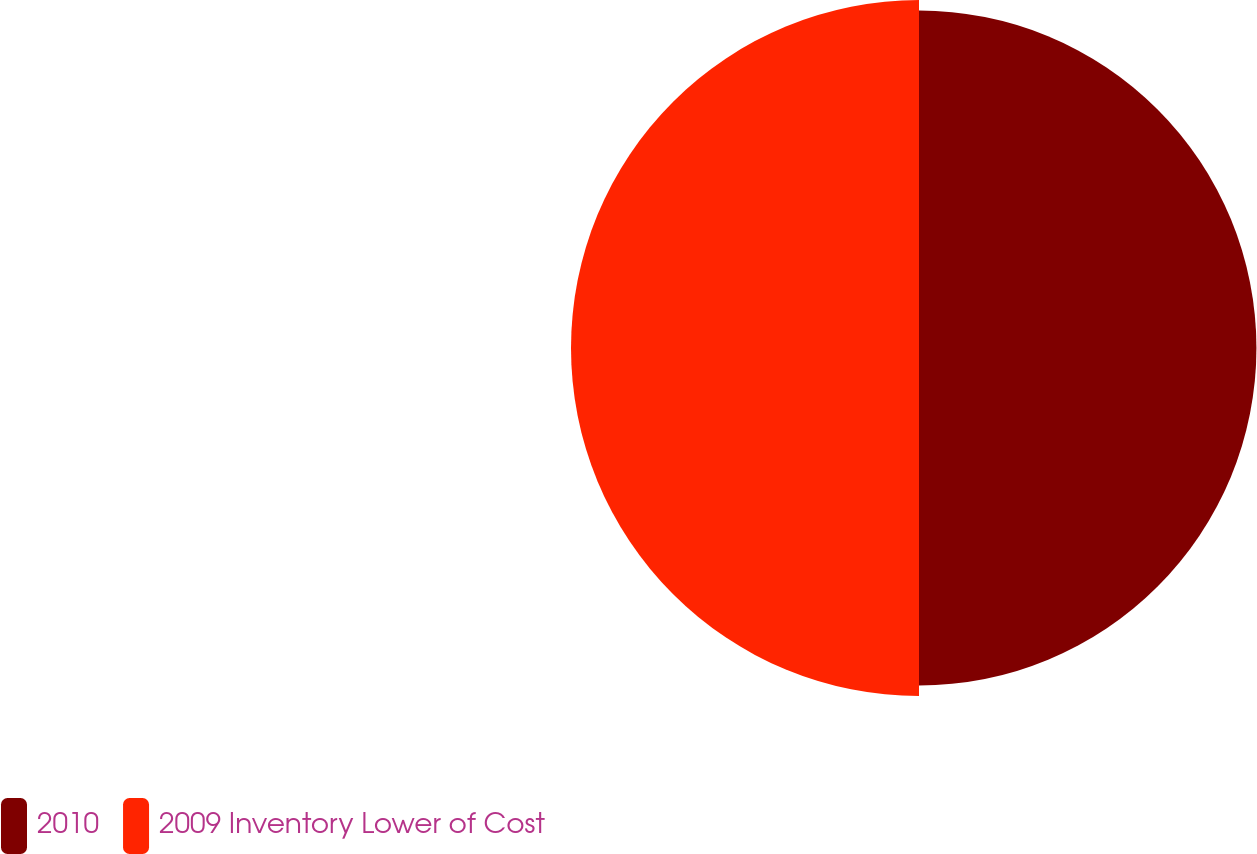Convert chart to OTSL. <chart><loc_0><loc_0><loc_500><loc_500><pie_chart><fcel>2010<fcel>2009 Inventory Lower of Cost<nl><fcel>49.23%<fcel>50.77%<nl></chart> 